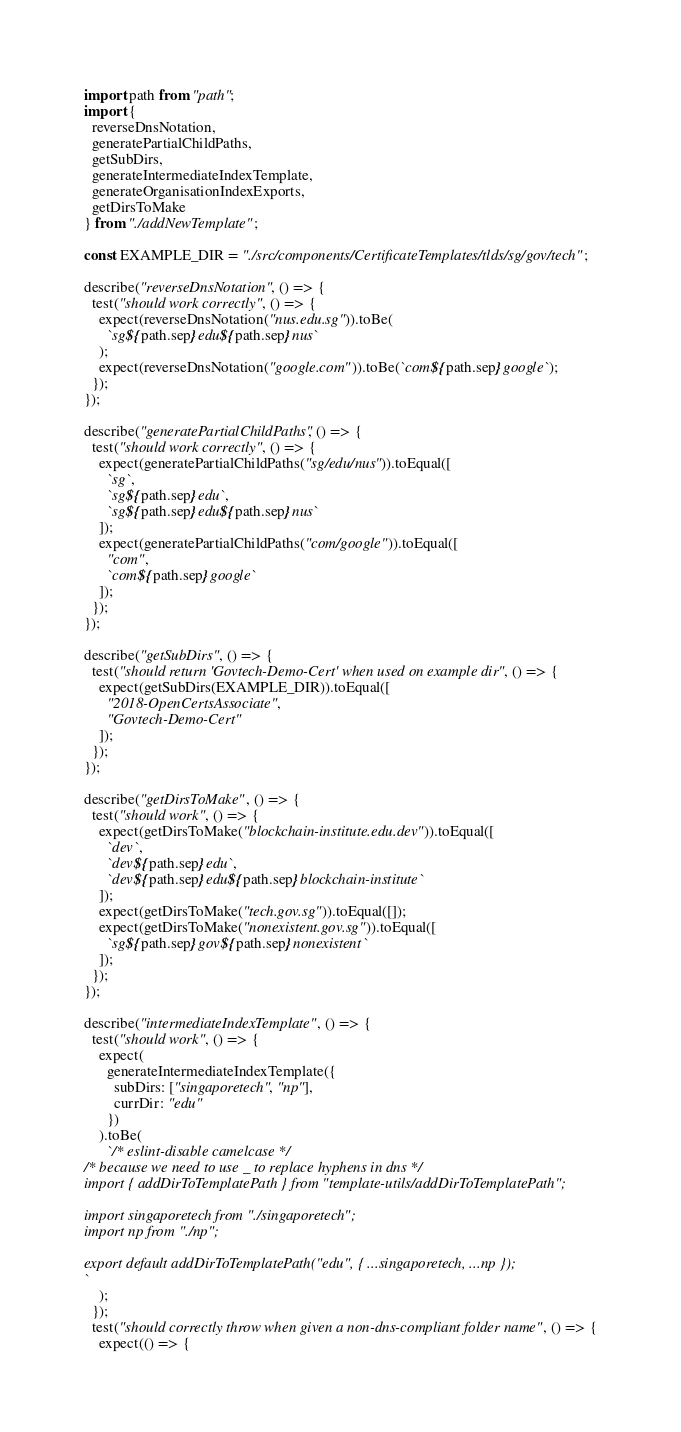Convert code to text. <code><loc_0><loc_0><loc_500><loc_500><_JavaScript_>import path from "path";
import {
  reverseDnsNotation,
  generatePartialChildPaths,
  getSubDirs,
  generateIntermediateIndexTemplate,
  generateOrganisationIndexExports,
  getDirsToMake
} from "./addNewTemplate";

const EXAMPLE_DIR = "./src/components/CertificateTemplates/tlds/sg/gov/tech";

describe("reverseDnsNotation", () => {
  test("should work correctly", () => {
    expect(reverseDnsNotation("nus.edu.sg")).toBe(
      `sg${path.sep}edu${path.sep}nus`
    );
    expect(reverseDnsNotation("google.com")).toBe(`com${path.sep}google`);
  });
});

describe("generatePartialChildPaths", () => {
  test("should work correctly", () => {
    expect(generatePartialChildPaths("sg/edu/nus")).toEqual([
      `sg`,
      `sg${path.sep}edu`,
      `sg${path.sep}edu${path.sep}nus`
    ]);
    expect(generatePartialChildPaths("com/google")).toEqual([
      "com",
      `com${path.sep}google`
    ]);
  });
});

describe("getSubDirs", () => {
  test("should return 'Govtech-Demo-Cert' when used on example dir", () => {
    expect(getSubDirs(EXAMPLE_DIR)).toEqual([
      "2018-OpenCertsAssociate",
      "Govtech-Demo-Cert"
    ]);
  });
});

describe("getDirsToMake", () => {
  test("should work", () => {
    expect(getDirsToMake("blockchain-institute.edu.dev")).toEqual([
      `dev`,
      `dev${path.sep}edu`,
      `dev${path.sep}edu${path.sep}blockchain-institute`
    ]);
    expect(getDirsToMake("tech.gov.sg")).toEqual([]);
    expect(getDirsToMake("nonexistent.gov.sg")).toEqual([
      `sg${path.sep}gov${path.sep}nonexistent`
    ]);
  });
});

describe("intermediateIndexTemplate", () => {
  test("should work", () => {
    expect(
      generateIntermediateIndexTemplate({
        subDirs: ["singaporetech", "np"],
        currDir: "edu"
      })
    ).toBe(
      `/* eslint-disable camelcase */
/* because we need to use _ to replace hyphens in dns */
import { addDirToTemplatePath } from "template-utils/addDirToTemplatePath";

import singaporetech from "./singaporetech";
import np from "./np";

export default addDirToTemplatePath("edu", { ...singaporetech, ...np });
`
    );
  });
  test("should correctly throw when given a non-dns-compliant folder name", () => {
    expect(() => {</code> 